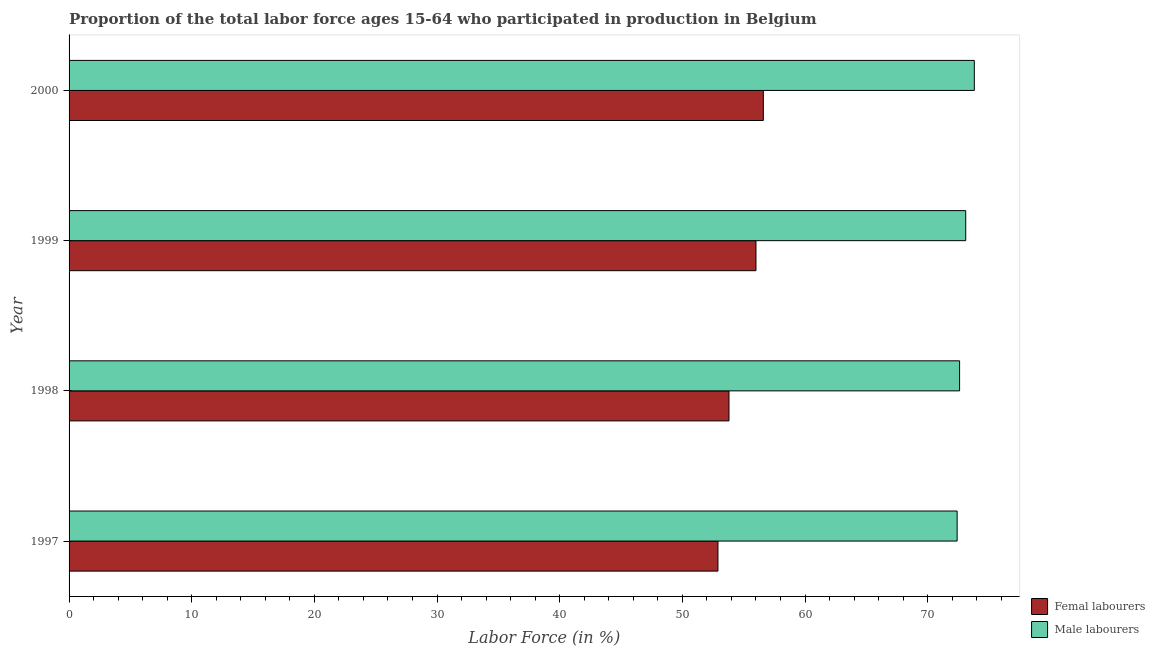How many different coloured bars are there?
Your response must be concise. 2. How many groups of bars are there?
Provide a short and direct response. 4. Are the number of bars per tick equal to the number of legend labels?
Your answer should be compact. Yes. How many bars are there on the 4th tick from the bottom?
Offer a terse response. 2. Across all years, what is the maximum percentage of male labour force?
Your response must be concise. 73.8. Across all years, what is the minimum percentage of female labor force?
Provide a short and direct response. 52.9. In which year was the percentage of male labour force minimum?
Offer a terse response. 1997. What is the total percentage of female labor force in the graph?
Offer a very short reply. 219.3. What is the difference between the percentage of male labour force in 1998 and the percentage of female labor force in 1999?
Your answer should be very brief. 16.6. What is the average percentage of female labor force per year?
Provide a succinct answer. 54.83. In the year 1997, what is the difference between the percentage of female labor force and percentage of male labour force?
Your answer should be compact. -19.5. What is the ratio of the percentage of female labor force in 1997 to that in 2000?
Provide a short and direct response. 0.94. What is the difference between the highest and the second highest percentage of female labor force?
Your response must be concise. 0.6. In how many years, is the percentage of female labor force greater than the average percentage of female labor force taken over all years?
Your response must be concise. 2. What does the 2nd bar from the top in 1997 represents?
Your response must be concise. Femal labourers. What does the 1st bar from the bottom in 1998 represents?
Make the answer very short. Femal labourers. How many years are there in the graph?
Ensure brevity in your answer.  4. Are the values on the major ticks of X-axis written in scientific E-notation?
Give a very brief answer. No. Does the graph contain any zero values?
Make the answer very short. No. Does the graph contain grids?
Provide a succinct answer. No. What is the title of the graph?
Your response must be concise. Proportion of the total labor force ages 15-64 who participated in production in Belgium. What is the label or title of the X-axis?
Your response must be concise. Labor Force (in %). What is the label or title of the Y-axis?
Keep it short and to the point. Year. What is the Labor Force (in %) in Femal labourers in 1997?
Your answer should be compact. 52.9. What is the Labor Force (in %) in Male labourers in 1997?
Make the answer very short. 72.4. What is the Labor Force (in %) of Femal labourers in 1998?
Your answer should be compact. 53.8. What is the Labor Force (in %) of Male labourers in 1998?
Offer a terse response. 72.6. What is the Labor Force (in %) in Femal labourers in 1999?
Your answer should be very brief. 56. What is the Labor Force (in %) in Male labourers in 1999?
Provide a short and direct response. 73.1. What is the Labor Force (in %) in Femal labourers in 2000?
Your answer should be very brief. 56.6. What is the Labor Force (in %) of Male labourers in 2000?
Make the answer very short. 73.8. Across all years, what is the maximum Labor Force (in %) of Femal labourers?
Provide a succinct answer. 56.6. Across all years, what is the maximum Labor Force (in %) of Male labourers?
Your response must be concise. 73.8. Across all years, what is the minimum Labor Force (in %) of Femal labourers?
Make the answer very short. 52.9. Across all years, what is the minimum Labor Force (in %) in Male labourers?
Provide a short and direct response. 72.4. What is the total Labor Force (in %) in Femal labourers in the graph?
Provide a succinct answer. 219.3. What is the total Labor Force (in %) in Male labourers in the graph?
Ensure brevity in your answer.  291.9. What is the difference between the Labor Force (in %) in Femal labourers in 1997 and that in 1999?
Your answer should be compact. -3.1. What is the difference between the Labor Force (in %) in Femal labourers in 1997 and that in 2000?
Keep it short and to the point. -3.7. What is the difference between the Labor Force (in %) in Femal labourers in 1998 and that in 1999?
Provide a short and direct response. -2.2. What is the difference between the Labor Force (in %) of Femal labourers in 1998 and that in 2000?
Your answer should be very brief. -2.8. What is the difference between the Labor Force (in %) of Femal labourers in 1999 and that in 2000?
Make the answer very short. -0.6. What is the difference between the Labor Force (in %) in Male labourers in 1999 and that in 2000?
Provide a short and direct response. -0.7. What is the difference between the Labor Force (in %) in Femal labourers in 1997 and the Labor Force (in %) in Male labourers in 1998?
Offer a very short reply. -19.7. What is the difference between the Labor Force (in %) in Femal labourers in 1997 and the Labor Force (in %) in Male labourers in 1999?
Keep it short and to the point. -20.2. What is the difference between the Labor Force (in %) in Femal labourers in 1997 and the Labor Force (in %) in Male labourers in 2000?
Give a very brief answer. -20.9. What is the difference between the Labor Force (in %) in Femal labourers in 1998 and the Labor Force (in %) in Male labourers in 1999?
Make the answer very short. -19.3. What is the difference between the Labor Force (in %) of Femal labourers in 1999 and the Labor Force (in %) of Male labourers in 2000?
Your answer should be compact. -17.8. What is the average Labor Force (in %) of Femal labourers per year?
Make the answer very short. 54.83. What is the average Labor Force (in %) of Male labourers per year?
Your response must be concise. 72.97. In the year 1997, what is the difference between the Labor Force (in %) of Femal labourers and Labor Force (in %) of Male labourers?
Give a very brief answer. -19.5. In the year 1998, what is the difference between the Labor Force (in %) in Femal labourers and Labor Force (in %) in Male labourers?
Provide a succinct answer. -18.8. In the year 1999, what is the difference between the Labor Force (in %) in Femal labourers and Labor Force (in %) in Male labourers?
Offer a very short reply. -17.1. In the year 2000, what is the difference between the Labor Force (in %) in Femal labourers and Labor Force (in %) in Male labourers?
Your answer should be compact. -17.2. What is the ratio of the Labor Force (in %) of Femal labourers in 1997 to that in 1998?
Provide a succinct answer. 0.98. What is the ratio of the Labor Force (in %) of Femal labourers in 1997 to that in 1999?
Make the answer very short. 0.94. What is the ratio of the Labor Force (in %) of Femal labourers in 1997 to that in 2000?
Your answer should be compact. 0.93. What is the ratio of the Labor Force (in %) in Femal labourers in 1998 to that in 1999?
Offer a terse response. 0.96. What is the ratio of the Labor Force (in %) in Male labourers in 1998 to that in 1999?
Make the answer very short. 0.99. What is the ratio of the Labor Force (in %) in Femal labourers in 1998 to that in 2000?
Your answer should be very brief. 0.95. What is the ratio of the Labor Force (in %) in Male labourers in 1998 to that in 2000?
Provide a succinct answer. 0.98. What is the ratio of the Labor Force (in %) in Femal labourers in 1999 to that in 2000?
Provide a short and direct response. 0.99. What is the difference between the highest and the lowest Labor Force (in %) in Femal labourers?
Offer a very short reply. 3.7. What is the difference between the highest and the lowest Labor Force (in %) of Male labourers?
Provide a short and direct response. 1.4. 